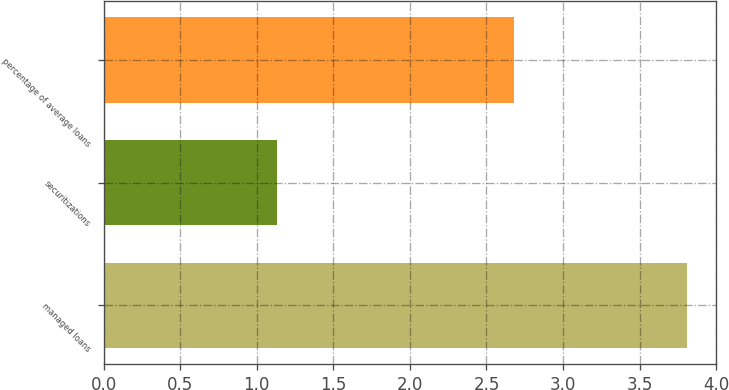Convert chart. <chart><loc_0><loc_0><loc_500><loc_500><bar_chart><fcel>managed loans<fcel>securitizations<fcel>percentage of average loans<nl><fcel>3.81<fcel>1.13<fcel>2.68<nl></chart> 